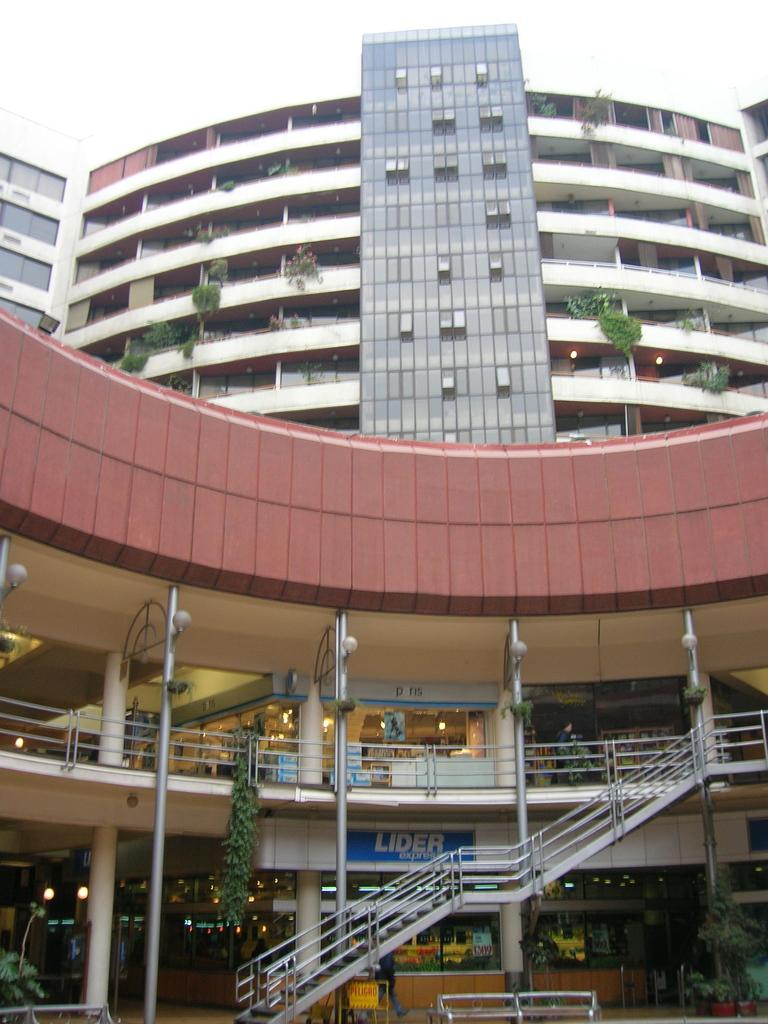<image>
Render a clear and concise summary of the photo. Lider Express is on the ground level of a two story shopping center. 